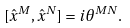<formula> <loc_0><loc_0><loc_500><loc_500>[ { \hat { x } } ^ { M } , { \hat { x } } ^ { N } ] = i \theta ^ { M N } .</formula> 